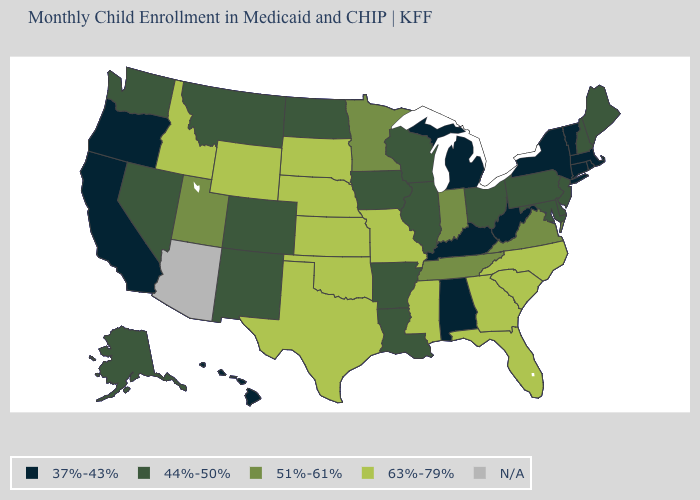Name the states that have a value in the range 63%-79%?
Write a very short answer. Florida, Georgia, Idaho, Kansas, Mississippi, Missouri, Nebraska, North Carolina, Oklahoma, South Carolina, South Dakota, Texas, Wyoming. What is the highest value in states that border Oregon?
Keep it brief. 63%-79%. What is the value of Maryland?
Answer briefly. 44%-50%. What is the value of Connecticut?
Give a very brief answer. 37%-43%. What is the lowest value in states that border Minnesota?
Keep it brief. 44%-50%. Among the states that border Wyoming , does Colorado have the lowest value?
Keep it brief. Yes. Name the states that have a value in the range 63%-79%?
Be succinct. Florida, Georgia, Idaho, Kansas, Mississippi, Missouri, Nebraska, North Carolina, Oklahoma, South Carolina, South Dakota, Texas, Wyoming. What is the value of Rhode Island?
Short answer required. 37%-43%. What is the lowest value in the USA?
Keep it brief. 37%-43%. Which states have the lowest value in the Northeast?
Short answer required. Connecticut, Massachusetts, New York, Rhode Island, Vermont. What is the lowest value in the West?
Give a very brief answer. 37%-43%. Does the first symbol in the legend represent the smallest category?
Be succinct. Yes. Which states hav the highest value in the South?
Short answer required. Florida, Georgia, Mississippi, North Carolina, Oklahoma, South Carolina, Texas. Is the legend a continuous bar?
Concise answer only. No. Does the first symbol in the legend represent the smallest category?
Be succinct. Yes. 